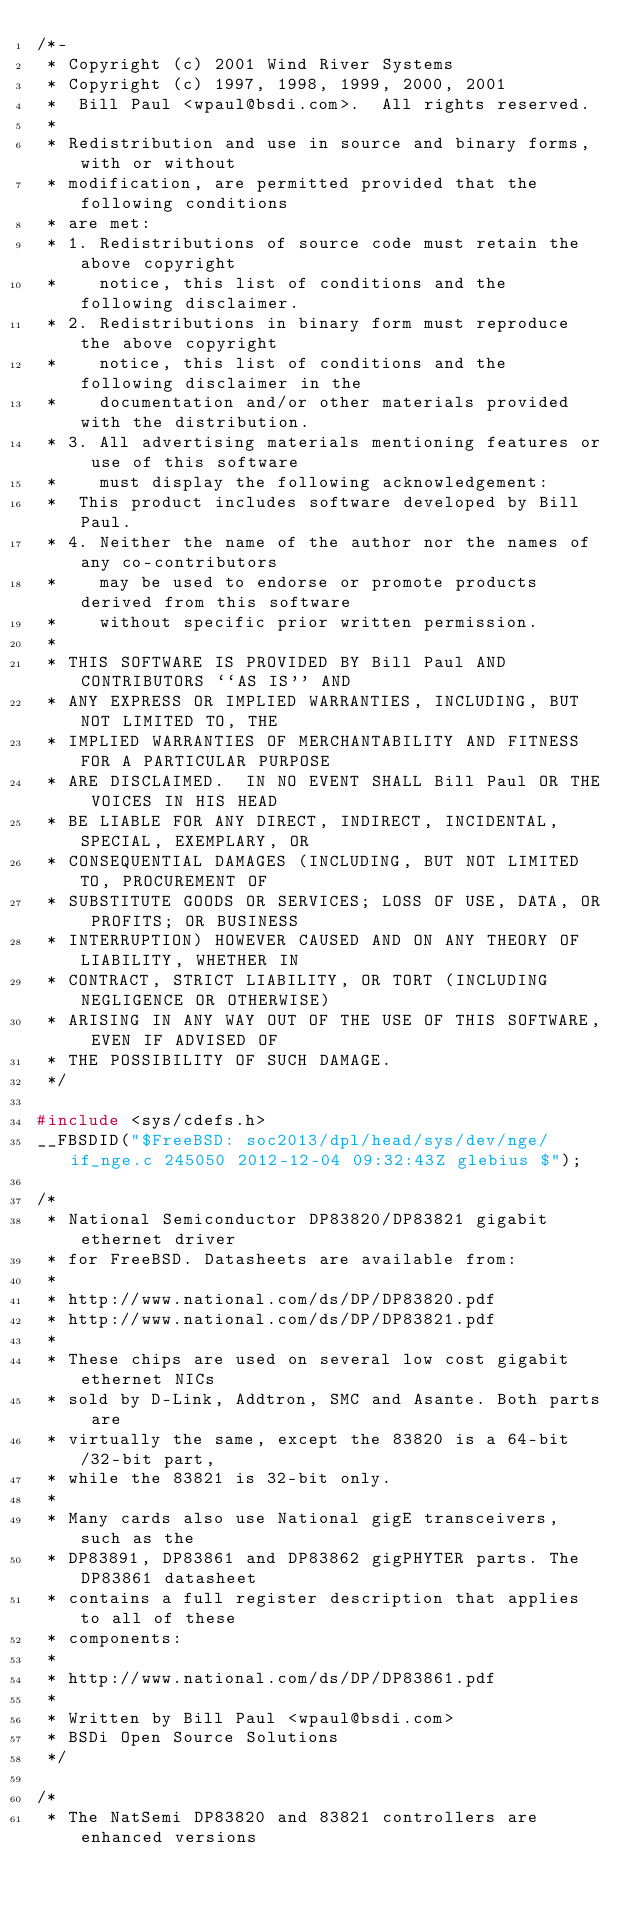Convert code to text. <code><loc_0><loc_0><loc_500><loc_500><_C_>/*-
 * Copyright (c) 2001 Wind River Systems
 * Copyright (c) 1997, 1998, 1999, 2000, 2001
 *	Bill Paul <wpaul@bsdi.com>.  All rights reserved.
 *
 * Redistribution and use in source and binary forms, with or without
 * modification, are permitted provided that the following conditions
 * are met:
 * 1. Redistributions of source code must retain the above copyright
 *    notice, this list of conditions and the following disclaimer.
 * 2. Redistributions in binary form must reproduce the above copyright
 *    notice, this list of conditions and the following disclaimer in the
 *    documentation and/or other materials provided with the distribution.
 * 3. All advertising materials mentioning features or use of this software
 *    must display the following acknowledgement:
 *	This product includes software developed by Bill Paul.
 * 4. Neither the name of the author nor the names of any co-contributors
 *    may be used to endorse or promote products derived from this software
 *    without specific prior written permission.
 *
 * THIS SOFTWARE IS PROVIDED BY Bill Paul AND CONTRIBUTORS ``AS IS'' AND
 * ANY EXPRESS OR IMPLIED WARRANTIES, INCLUDING, BUT NOT LIMITED TO, THE
 * IMPLIED WARRANTIES OF MERCHANTABILITY AND FITNESS FOR A PARTICULAR PURPOSE
 * ARE DISCLAIMED.  IN NO EVENT SHALL Bill Paul OR THE VOICES IN HIS HEAD
 * BE LIABLE FOR ANY DIRECT, INDIRECT, INCIDENTAL, SPECIAL, EXEMPLARY, OR
 * CONSEQUENTIAL DAMAGES (INCLUDING, BUT NOT LIMITED TO, PROCUREMENT OF
 * SUBSTITUTE GOODS OR SERVICES; LOSS OF USE, DATA, OR PROFITS; OR BUSINESS
 * INTERRUPTION) HOWEVER CAUSED AND ON ANY THEORY OF LIABILITY, WHETHER IN
 * CONTRACT, STRICT LIABILITY, OR TORT (INCLUDING NEGLIGENCE OR OTHERWISE)
 * ARISING IN ANY WAY OUT OF THE USE OF THIS SOFTWARE, EVEN IF ADVISED OF
 * THE POSSIBILITY OF SUCH DAMAGE.
 */

#include <sys/cdefs.h>
__FBSDID("$FreeBSD: soc2013/dpl/head/sys/dev/nge/if_nge.c 245050 2012-12-04 09:32:43Z glebius $");

/*
 * National Semiconductor DP83820/DP83821 gigabit ethernet driver
 * for FreeBSD. Datasheets are available from:
 *
 * http://www.national.com/ds/DP/DP83820.pdf
 * http://www.national.com/ds/DP/DP83821.pdf
 *
 * These chips are used on several low cost gigabit ethernet NICs
 * sold by D-Link, Addtron, SMC and Asante. Both parts are
 * virtually the same, except the 83820 is a 64-bit/32-bit part,
 * while the 83821 is 32-bit only.
 *
 * Many cards also use National gigE transceivers, such as the
 * DP83891, DP83861 and DP83862 gigPHYTER parts. The DP83861 datasheet
 * contains a full register description that applies to all of these
 * components:
 *
 * http://www.national.com/ds/DP/DP83861.pdf
 *
 * Written by Bill Paul <wpaul@bsdi.com>
 * BSDi Open Source Solutions
 */

/*
 * The NatSemi DP83820 and 83821 controllers are enhanced versions</code> 